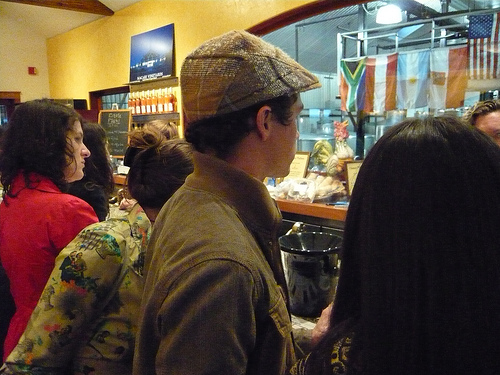<image>
Can you confirm if the flag is in front of the man? Yes. The flag is positioned in front of the man, appearing closer to the camera viewpoint. 